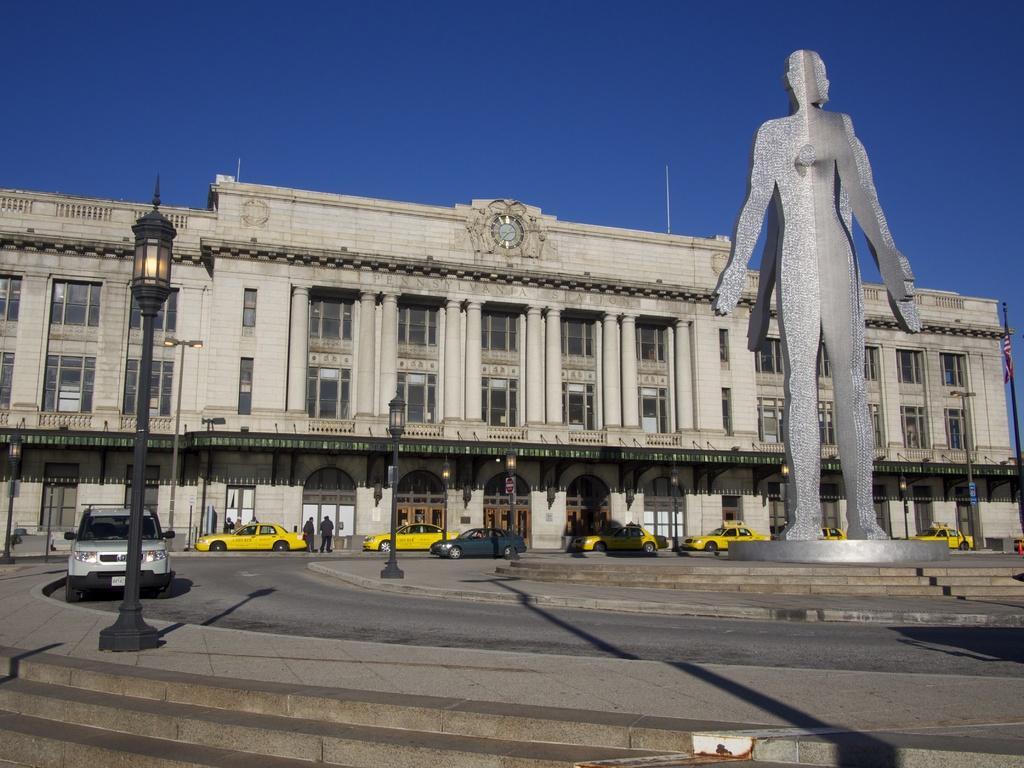In one or two sentences, can you explain what this image depicts? In this image in the center there is one building, and in the foreground there is one statue and also there are some vehicles on the road. At the bottom there is a road and some stairs, on the left side there is one pole and light. On the top of the image there is sky and and in the center there are some persons. 